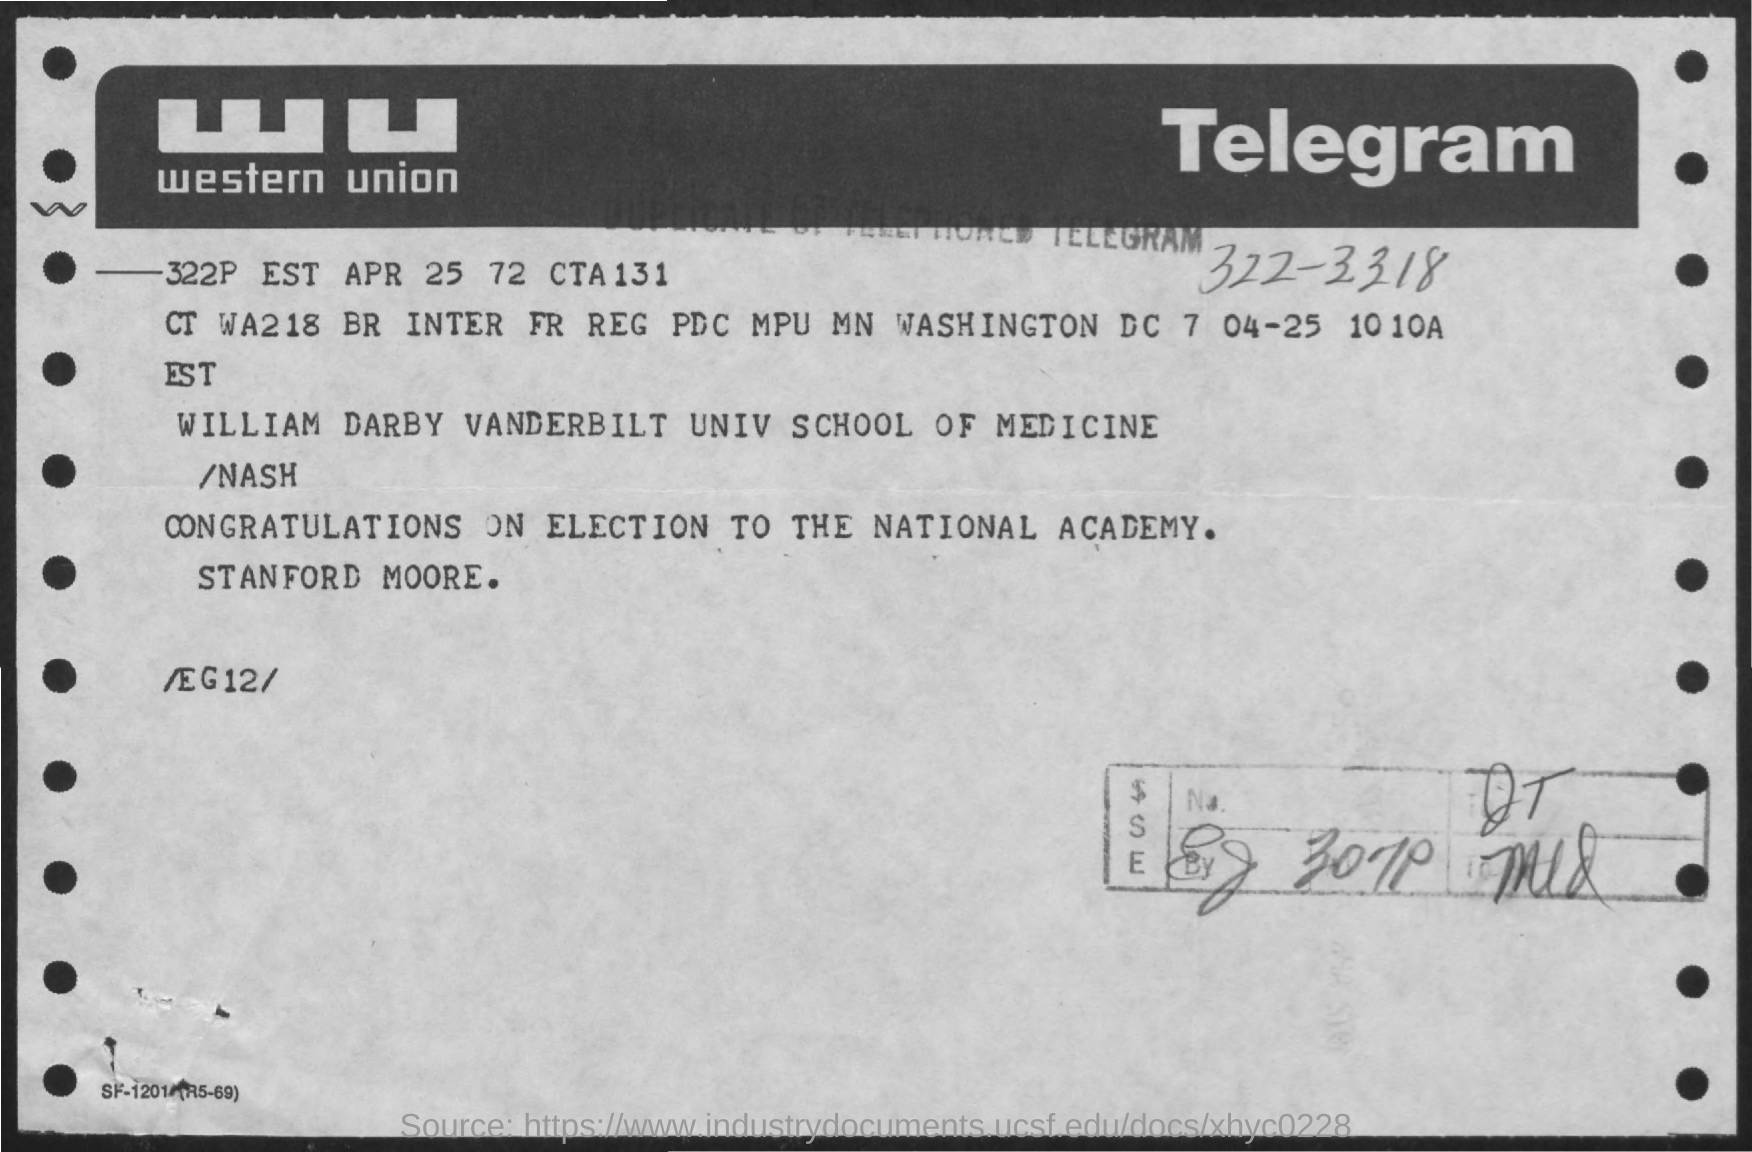Give some essential details in this illustration. This is a type of communication that is known as Telegram. The telegram message read, "Congratulations on your election to the National Academy. 